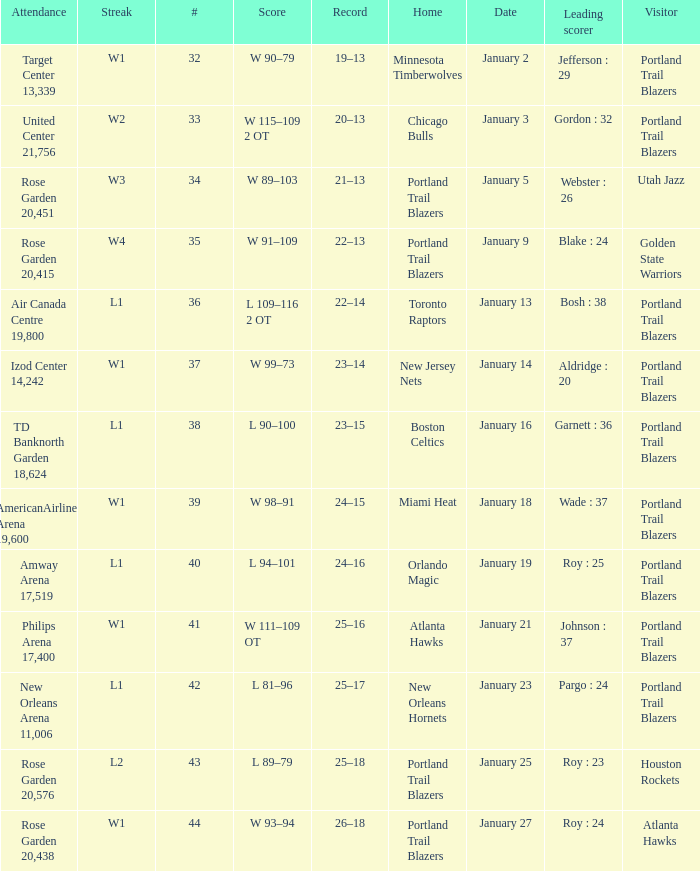Who are all the visitor with a record of 25–18 Houston Rockets. 